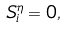<formula> <loc_0><loc_0><loc_500><loc_500>S ^ { \eta } _ { i } = 0 ,</formula> 